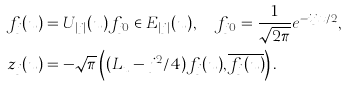Convert formula to latex. <formula><loc_0><loc_0><loc_500><loc_500>f _ { j } ( u ) & = U _ { | j | } ( u ) f _ { j 0 } \in E _ { | j | } ( u ) , \quad f _ { j 0 } = \frac { 1 } { \sqrt { 2 \pi } } e ^ { - i j x / 2 } , \\ z _ { j } ( u ) & = - \sqrt { \pi } \left ( ( L _ { u } - j ^ { 2 } / 4 ) f _ { j } ( u ) , \overline { f _ { j } ( u ) } \right ) .</formula> 